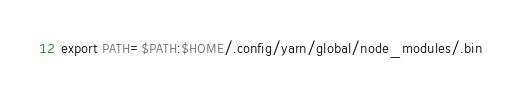Convert code to text. <code><loc_0><loc_0><loc_500><loc_500><_Bash_>export PATH=$PATH:$HOME/.config/yarn/global/node_modules/.bin
</code> 